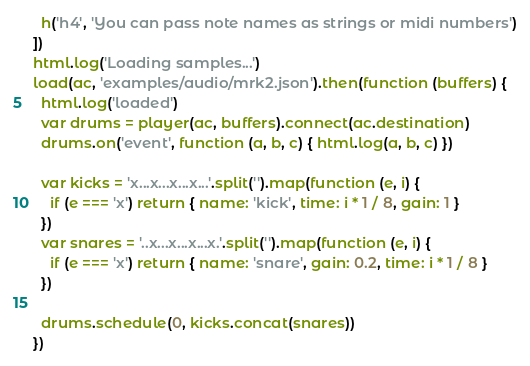Convert code to text. <code><loc_0><loc_0><loc_500><loc_500><_JavaScript_>  h('h4', 'You can pass note names as strings or midi numbers')
])
html.log('Loading samples...')
load(ac, 'examples/audio/mrk2.json').then(function (buffers) {
  html.log('loaded')
  var drums = player(ac, buffers).connect(ac.destination)
  drums.on('event', function (a, b, c) { html.log(a, b, c) })

  var kicks = 'x...x...x...x...'.split('').map(function (e, i) {
    if (e === 'x') return { name: 'kick', time: i * 1 / 8, gain: 1 }
  })
  var snares = '..x...x...x...x.'.split('').map(function (e, i) {
    if (e === 'x') return { name: 'snare', gain: 0.2, time: i * 1 / 8 }
  })

  drums.schedule(0, kicks.concat(snares))
})
</code> 